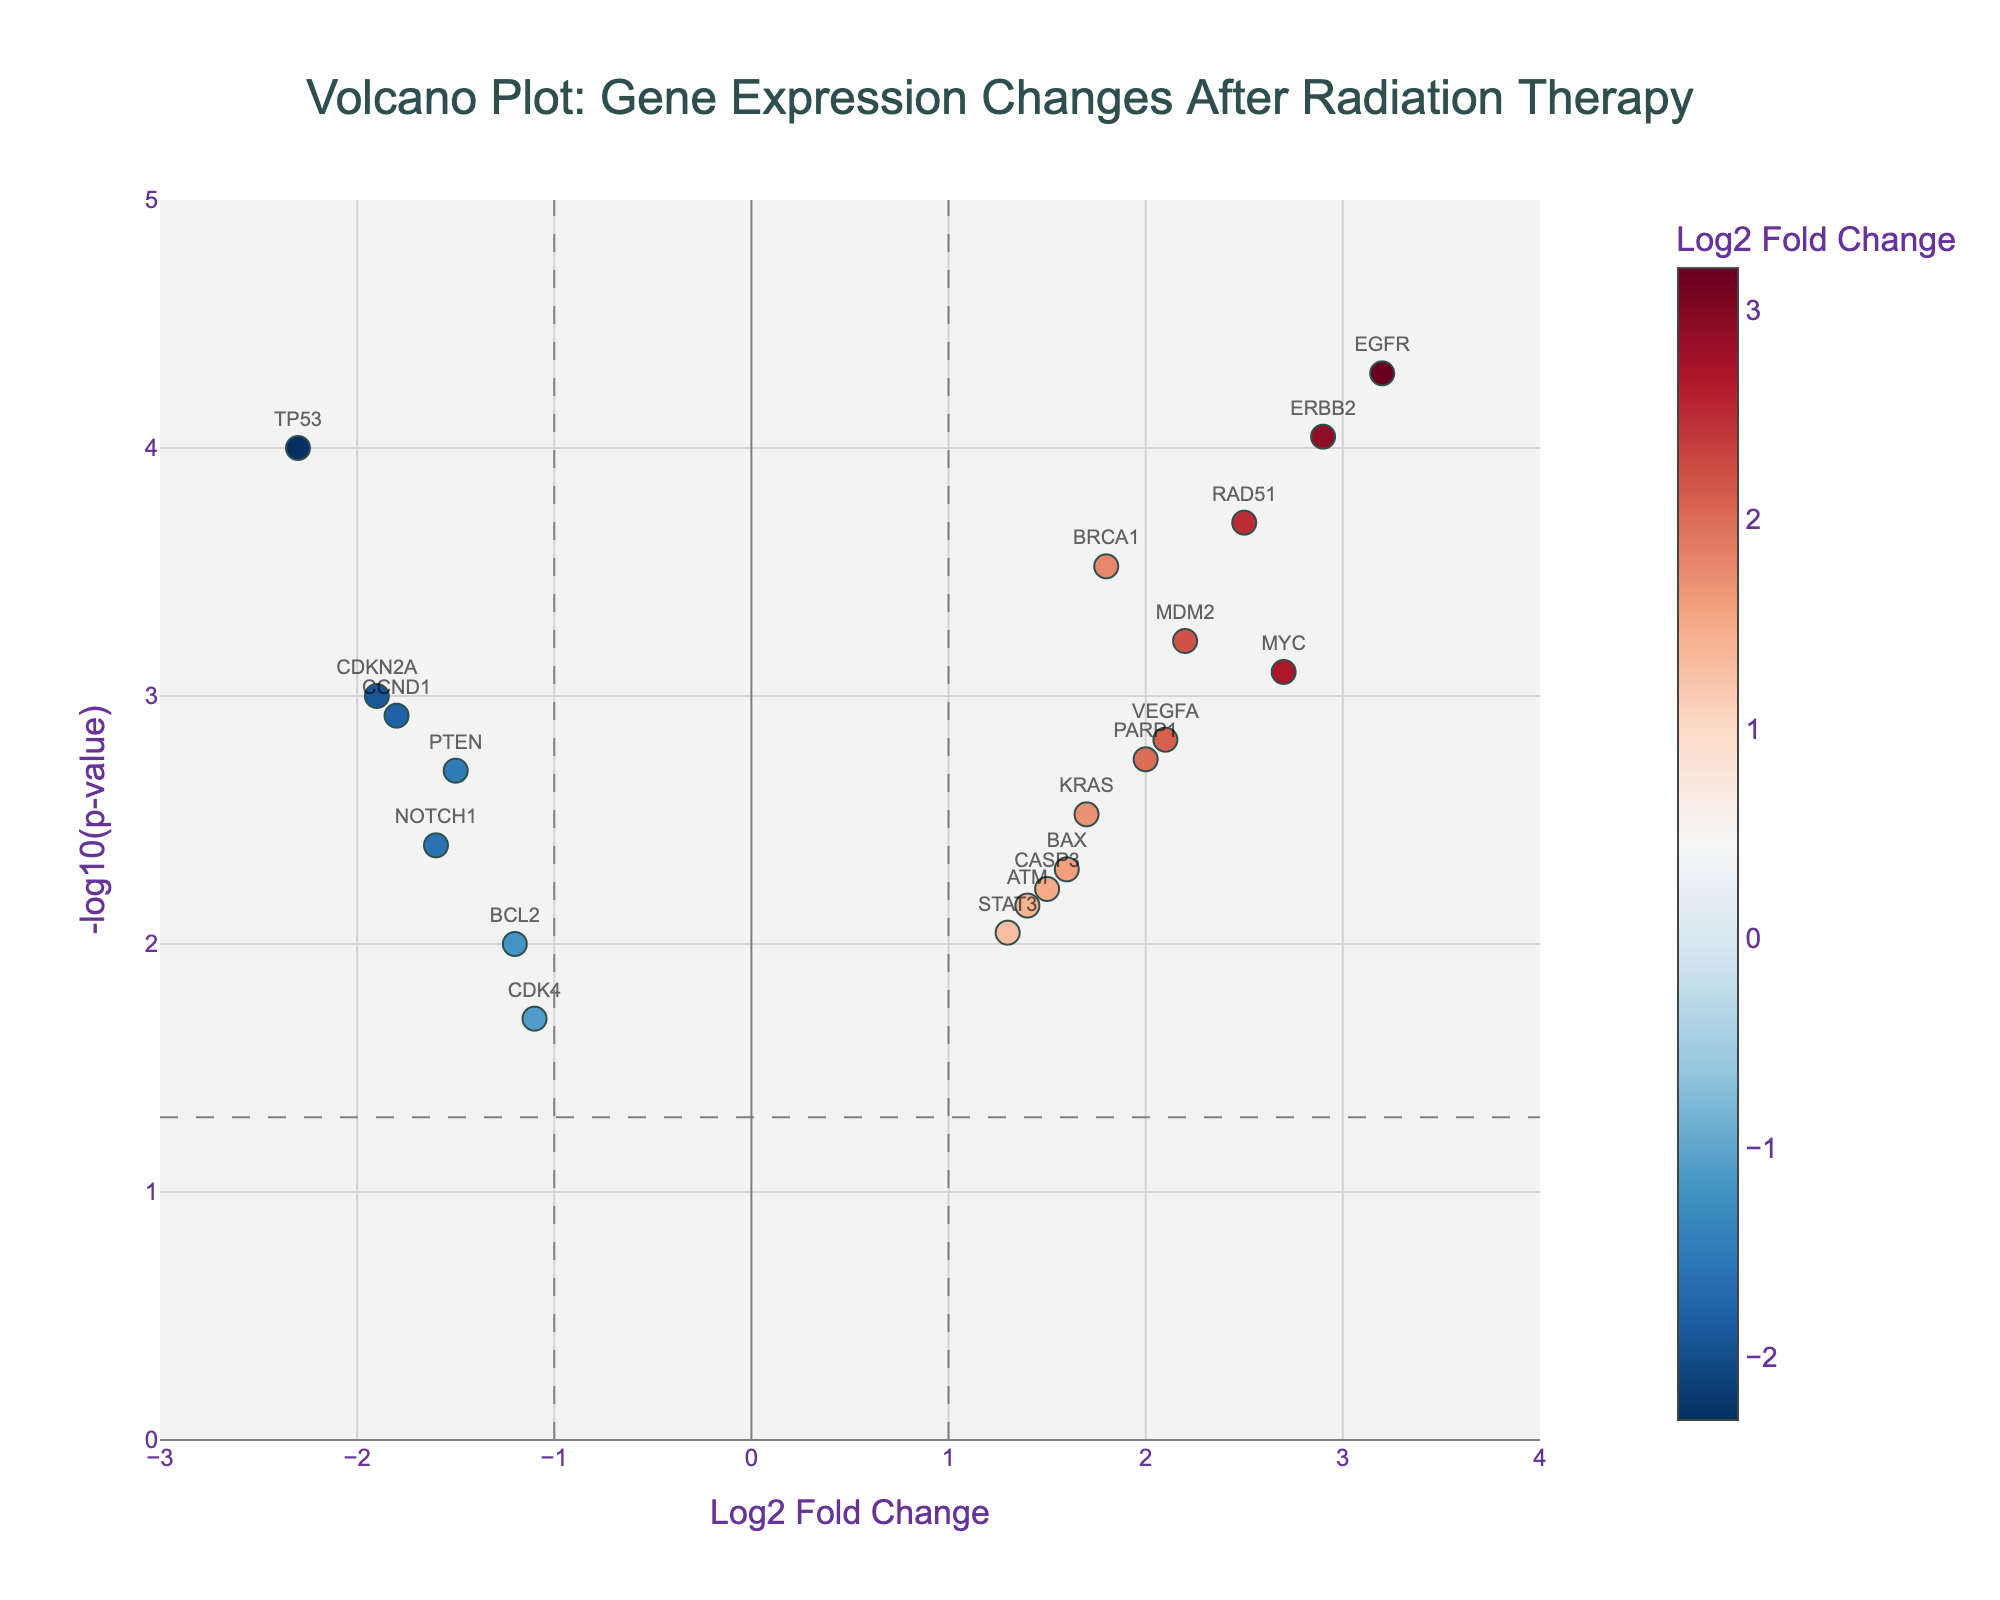What is the title of the plot? The title is generally at the top of the plot. Reading it directly gives us the answer.
Answer: Volcano Plot: Gene Expression Changes After Radiation Therapy How many genes have a p-value less than 0.05? The horizontal line at y = -log10(0.05) indicates the p-value threshold. Count the number of points above this line.
Answer: 18 Which gene shows the greatest log2 fold change after radiation therapy? By looking along the x-axis for the data point that is the farthest to the right, you'll identify the gene with the highest log2 fold change.
Answer: EGFR Which gene has the highest statistical significance? The gene with the highest significance would be the one with the highest y-value, which corresponds to the smallest p-value.
Answer: EGFR How many genes show significant down-regulation (log2 fold change < -1) after radiation therapy? Look for data points to the left of the x = -1 line, and above the horizontal line representing p-value threshold. Count these points.
Answer: 4 Compare the log2 fold change of BRCA1 and MYC, which is higher? Locate BRCA1 and MYC on the plot. BRCA1 has a log2 fold change of 1.8 and MYC has 2.7. Compare these values.
Answer: MYC What is the log2 fold change of VEGFA? Locate VEGFA on the x-axis and read its corresponding log2 fold change value.
Answer: 2.1 Which gene is down-regulated the most after radiation therapy? Look along the x-axis to find the data point that is the farthest to the left.
Answer: TP53 Are there more up-regulated or down-regulated genes after radiation therapy? Count the number of points to the right of x = 1 for up-regulated and to the left of x = -1 for down-regulated, then compare.
Answer: More up-regulated What is the threshold p-value used to indicate significance in this plot? The horizontal line represents the threshold p-value for significance, given by the y-value at this line.
Answer: 0.05 